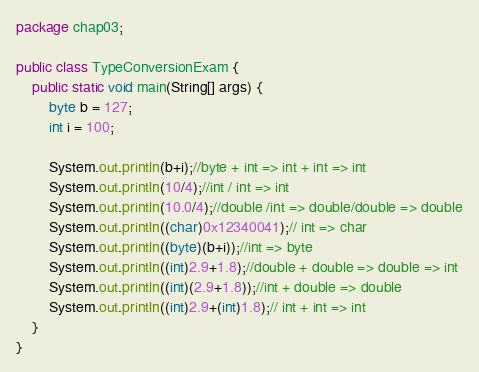<code> <loc_0><loc_0><loc_500><loc_500><_Java_>package chap03;

public class TypeConversionExam {
	public static void main(String[] args) {
		byte b = 127;
		int i = 100;
		
		System.out.println(b+i);//byte + int => int + int => int
		System.out.println(10/4);//int / int => int
		System.out.println(10.0/4);//double /int => double/double => double
		System.out.println((char)0x12340041);// int => char
		System.out.println((byte)(b+i));//int => byte
		System.out.println((int)2.9+1.8);//double + double => double => int
		System.out.println((int)(2.9+1.8));//int + double => double
		System.out.println((int)2.9+(int)1.8);// int + int => int
	}
}
</code> 